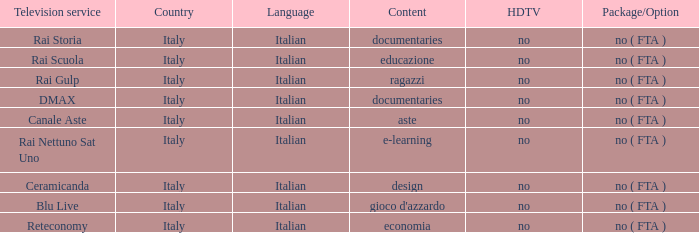What is the HDTV for the Rai Nettuno Sat Uno Television service? No. 